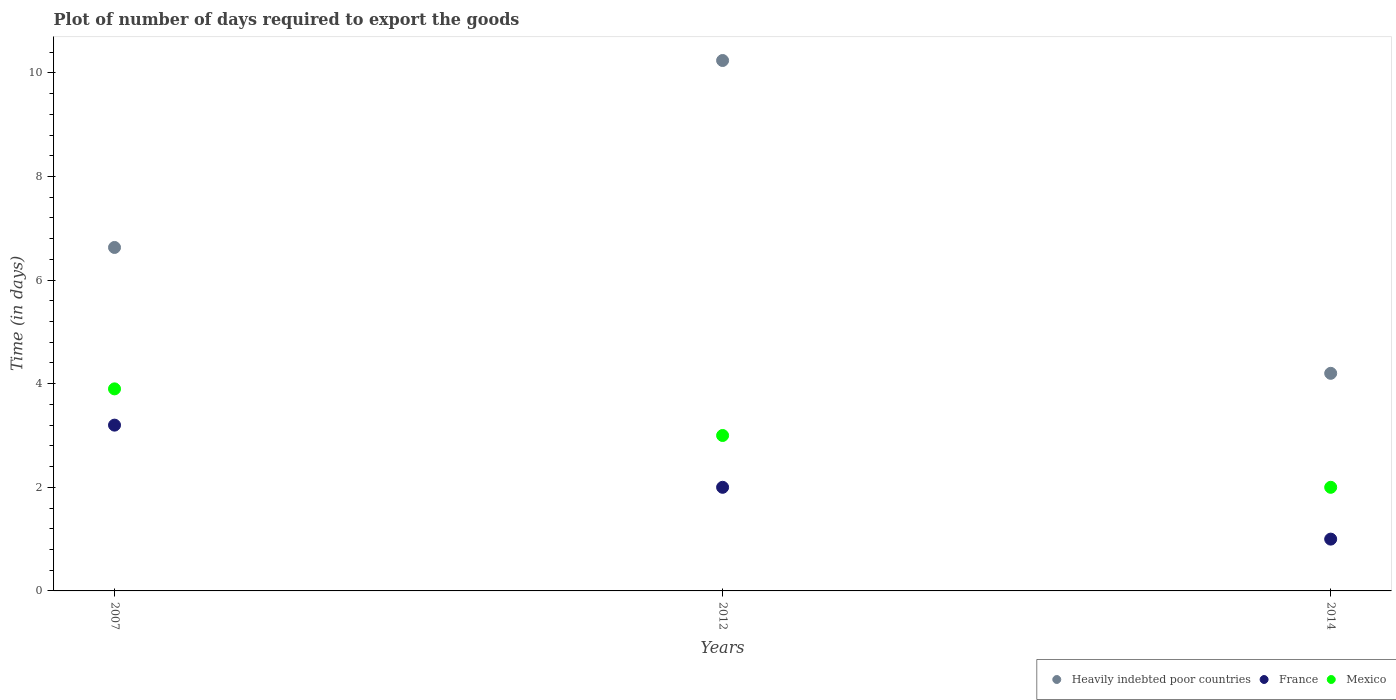How many different coloured dotlines are there?
Offer a very short reply. 3. What is the time required to export goods in France in 2007?
Your answer should be very brief. 3.2. Across all years, what is the maximum time required to export goods in Heavily indebted poor countries?
Give a very brief answer. 10.24. In which year was the time required to export goods in France maximum?
Your response must be concise. 2007. In which year was the time required to export goods in Heavily indebted poor countries minimum?
Provide a short and direct response. 2014. What is the difference between the time required to export goods in France in 2012 and that in 2014?
Make the answer very short. 1. What is the difference between the time required to export goods in France in 2014 and the time required to export goods in Heavily indebted poor countries in 2012?
Ensure brevity in your answer.  -9.24. What is the average time required to export goods in France per year?
Offer a terse response. 2.07. In the year 2012, what is the difference between the time required to export goods in Heavily indebted poor countries and time required to export goods in Mexico?
Your answer should be compact. 7.24. In how many years, is the time required to export goods in France greater than 6 days?
Keep it short and to the point. 0. Is the time required to export goods in Mexico in 2007 less than that in 2014?
Make the answer very short. No. Is the difference between the time required to export goods in Heavily indebted poor countries in 2012 and 2014 greater than the difference between the time required to export goods in Mexico in 2012 and 2014?
Provide a succinct answer. Yes. What is the difference between the highest and the second highest time required to export goods in Heavily indebted poor countries?
Keep it short and to the point. 3.61. What is the difference between the highest and the lowest time required to export goods in Mexico?
Provide a succinct answer. 1.9. Is the sum of the time required to export goods in Mexico in 2007 and 2014 greater than the maximum time required to export goods in France across all years?
Offer a terse response. Yes. Is it the case that in every year, the sum of the time required to export goods in France and time required to export goods in Heavily indebted poor countries  is greater than the time required to export goods in Mexico?
Provide a short and direct response. Yes. Does the time required to export goods in Mexico monotonically increase over the years?
Provide a short and direct response. No. Is the time required to export goods in Heavily indebted poor countries strictly greater than the time required to export goods in France over the years?
Provide a short and direct response. Yes. What is the difference between two consecutive major ticks on the Y-axis?
Provide a succinct answer. 2. Does the graph contain grids?
Offer a very short reply. No. How are the legend labels stacked?
Make the answer very short. Horizontal. What is the title of the graph?
Ensure brevity in your answer.  Plot of number of days required to export the goods. Does "Montenegro" appear as one of the legend labels in the graph?
Make the answer very short. No. What is the label or title of the X-axis?
Make the answer very short. Years. What is the label or title of the Y-axis?
Provide a short and direct response. Time (in days). What is the Time (in days) in Heavily indebted poor countries in 2007?
Give a very brief answer. 6.63. What is the Time (in days) in France in 2007?
Ensure brevity in your answer.  3.2. What is the Time (in days) of Heavily indebted poor countries in 2012?
Your answer should be very brief. 10.24. What is the Time (in days) of Mexico in 2012?
Provide a succinct answer. 3. What is the Time (in days) of Heavily indebted poor countries in 2014?
Your response must be concise. 4.2. What is the Time (in days) in Mexico in 2014?
Your answer should be compact. 2. Across all years, what is the maximum Time (in days) of Heavily indebted poor countries?
Keep it short and to the point. 10.24. What is the total Time (in days) of Heavily indebted poor countries in the graph?
Your answer should be compact. 21.07. What is the total Time (in days) in France in the graph?
Offer a terse response. 6.2. What is the total Time (in days) of Mexico in the graph?
Provide a short and direct response. 8.9. What is the difference between the Time (in days) in Heavily indebted poor countries in 2007 and that in 2012?
Your answer should be very brief. -3.61. What is the difference between the Time (in days) of France in 2007 and that in 2012?
Your response must be concise. 1.2. What is the difference between the Time (in days) of Mexico in 2007 and that in 2012?
Your answer should be very brief. 0.9. What is the difference between the Time (in days) of Heavily indebted poor countries in 2007 and that in 2014?
Provide a short and direct response. 2.43. What is the difference between the Time (in days) in Mexico in 2007 and that in 2014?
Your answer should be compact. 1.9. What is the difference between the Time (in days) in Heavily indebted poor countries in 2012 and that in 2014?
Provide a short and direct response. 6.04. What is the difference between the Time (in days) of Mexico in 2012 and that in 2014?
Your response must be concise. 1. What is the difference between the Time (in days) of Heavily indebted poor countries in 2007 and the Time (in days) of France in 2012?
Offer a very short reply. 4.63. What is the difference between the Time (in days) in Heavily indebted poor countries in 2007 and the Time (in days) in Mexico in 2012?
Provide a succinct answer. 3.63. What is the difference between the Time (in days) of Heavily indebted poor countries in 2007 and the Time (in days) of France in 2014?
Offer a terse response. 5.63. What is the difference between the Time (in days) of Heavily indebted poor countries in 2007 and the Time (in days) of Mexico in 2014?
Provide a succinct answer. 4.63. What is the difference between the Time (in days) of France in 2007 and the Time (in days) of Mexico in 2014?
Give a very brief answer. 1.2. What is the difference between the Time (in days) of Heavily indebted poor countries in 2012 and the Time (in days) of France in 2014?
Make the answer very short. 9.24. What is the difference between the Time (in days) of Heavily indebted poor countries in 2012 and the Time (in days) of Mexico in 2014?
Your answer should be compact. 8.24. What is the difference between the Time (in days) in France in 2012 and the Time (in days) in Mexico in 2014?
Ensure brevity in your answer.  0. What is the average Time (in days) of Heavily indebted poor countries per year?
Offer a terse response. 7.02. What is the average Time (in days) in France per year?
Keep it short and to the point. 2.07. What is the average Time (in days) of Mexico per year?
Give a very brief answer. 2.97. In the year 2007, what is the difference between the Time (in days) of Heavily indebted poor countries and Time (in days) of France?
Your response must be concise. 3.43. In the year 2007, what is the difference between the Time (in days) of Heavily indebted poor countries and Time (in days) of Mexico?
Ensure brevity in your answer.  2.73. In the year 2012, what is the difference between the Time (in days) of Heavily indebted poor countries and Time (in days) of France?
Provide a succinct answer. 8.24. In the year 2012, what is the difference between the Time (in days) in Heavily indebted poor countries and Time (in days) in Mexico?
Your response must be concise. 7.24. In the year 2014, what is the difference between the Time (in days) of Heavily indebted poor countries and Time (in days) of Mexico?
Offer a terse response. 2.2. In the year 2014, what is the difference between the Time (in days) in France and Time (in days) in Mexico?
Offer a terse response. -1. What is the ratio of the Time (in days) of Heavily indebted poor countries in 2007 to that in 2012?
Provide a short and direct response. 0.65. What is the ratio of the Time (in days) of France in 2007 to that in 2012?
Your answer should be compact. 1.6. What is the ratio of the Time (in days) in Mexico in 2007 to that in 2012?
Ensure brevity in your answer.  1.3. What is the ratio of the Time (in days) of Heavily indebted poor countries in 2007 to that in 2014?
Your answer should be very brief. 1.58. What is the ratio of the Time (in days) of France in 2007 to that in 2014?
Your answer should be very brief. 3.2. What is the ratio of the Time (in days) of Mexico in 2007 to that in 2014?
Your response must be concise. 1.95. What is the ratio of the Time (in days) of Heavily indebted poor countries in 2012 to that in 2014?
Give a very brief answer. 2.44. What is the ratio of the Time (in days) in France in 2012 to that in 2014?
Your answer should be compact. 2. What is the ratio of the Time (in days) in Mexico in 2012 to that in 2014?
Offer a terse response. 1.5. What is the difference between the highest and the second highest Time (in days) of Heavily indebted poor countries?
Provide a short and direct response. 3.61. What is the difference between the highest and the second highest Time (in days) of France?
Your answer should be very brief. 1.2. What is the difference between the highest and the lowest Time (in days) in Heavily indebted poor countries?
Provide a short and direct response. 6.04. 